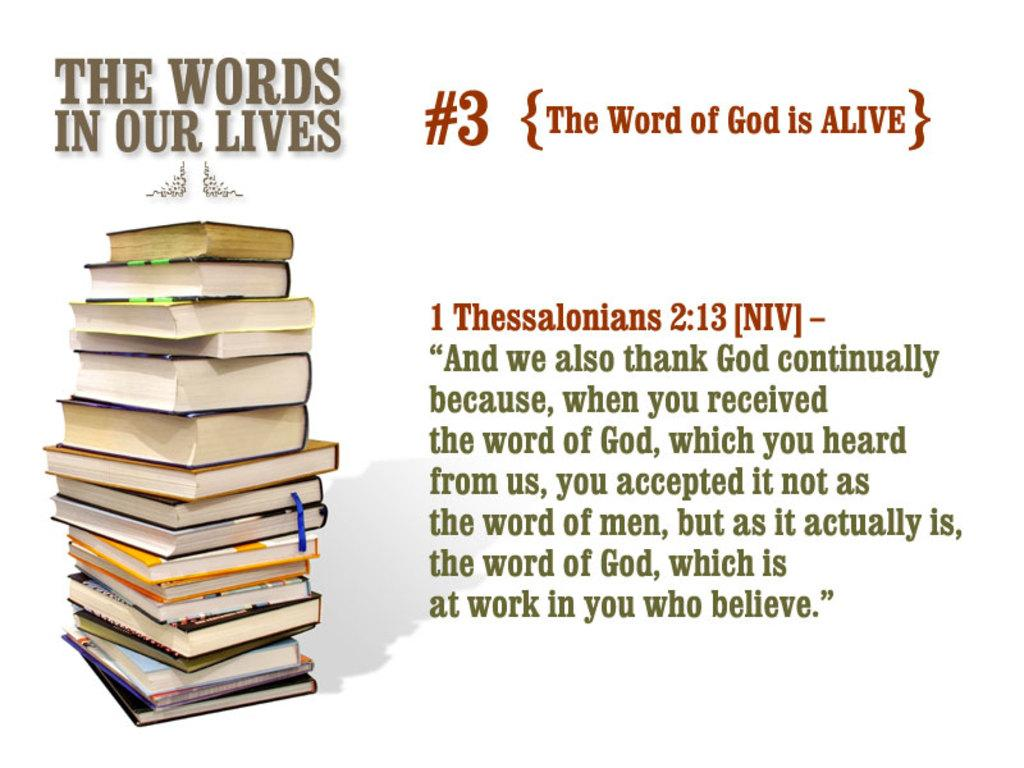What can be observed about the image in terms of its appearance? The image appears to be edited. What type of objects are present on the left side of the image? There are many books on the left side of the image. What is located on the right side of the image? There is an article on the right side of the image. What type of humor can be seen in the air surrounding the books in the image? There is no humor or air visible in the image; it only contains books and an article. 